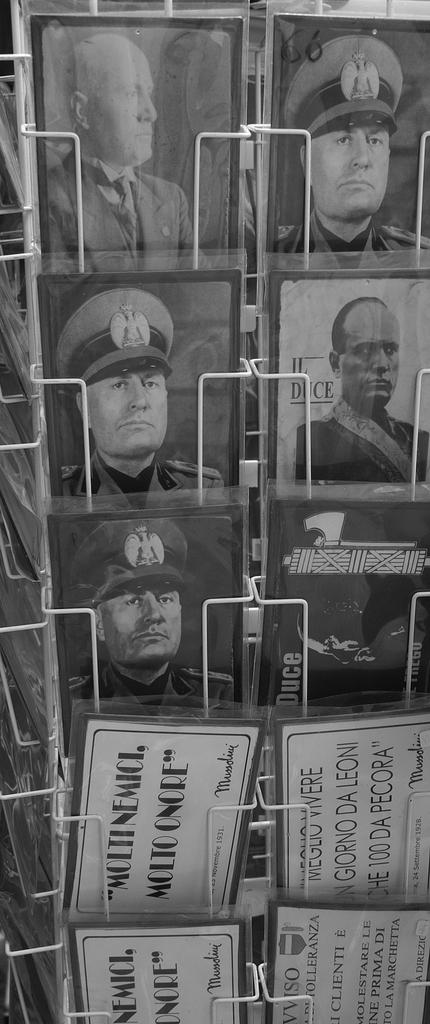What does the bottom postcard say?
Offer a very short reply. Moltinemici molto onore. 